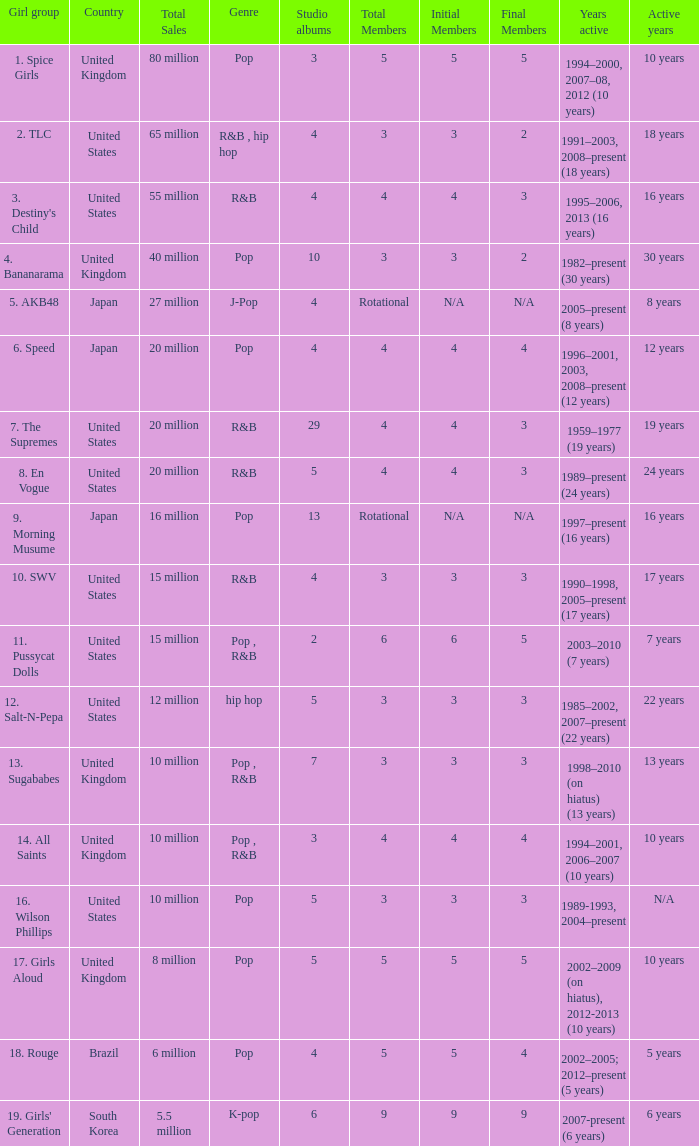Could you parse the entire table? {'header': ['Girl group', 'Country', 'Total Sales', 'Genre', 'Studio albums', 'Total Members', 'Initial Members', 'Final Members', 'Years active', 'Active years'], 'rows': [['1. Spice Girls', 'United Kingdom', '80 million', 'Pop', '3', '5', '5', '5', '1994–2000, 2007–08, 2012 (10 years)', '10 years'], ['2. TLC', 'United States', '65 million', 'R&B , hip hop', '4', '3', '3', '2', '1991–2003, 2008–present (18 years)', '18 years'], ["3. Destiny's Child", 'United States', '55 million', 'R&B', '4', '4', '4', '3', '1995–2006, 2013 (16 years)', '16 years'], ['4. Bananarama', 'United Kingdom', '40 million', 'Pop', '10', '3', '3', '2', '1982–present (30 years)', '30 years'], ['5. AKB48', 'Japan', '27 million', 'J-Pop', '4', 'Rotational', 'N/A', 'N/A', '2005–present (8 years)', '8 years'], ['6. Speed', 'Japan', '20 million', 'Pop', '4', '4', '4', '4', '1996–2001, 2003, 2008–present (12 years)', '12 years'], ['7. The Supremes', 'United States', '20 million', 'R&B', '29', '4', '4', '3', '1959–1977 (19 years)', '19 years'], ['8. En Vogue', 'United States', '20 million', 'R&B', '5', '4', '4', '3', '1989–present (24 years)', '24 years'], ['9. Morning Musume', 'Japan', '16 million', 'Pop', '13', 'Rotational', 'N/A', 'N/A', '1997–present (16 years)', '16 years'], ['10. SWV', 'United States', '15 million', 'R&B', '4', '3', '3', '3', '1990–1998, 2005–present (17 years)', '17 years'], ['11. Pussycat Dolls', 'United States', '15 million', 'Pop , R&B', '2', '6', '6', '5', '2003–2010 (7 years)', '7 years'], ['12. Salt-N-Pepa', 'United States', '12 million', 'hip hop', '5', '3', '3', '3', '1985–2002, 2007–present (22 years)', '22 years'], ['13. Sugababes', 'United Kingdom', '10 million', 'Pop , R&B', '7', '3', '3', '3', '1998–2010 (on hiatus) (13 years)', '13 years'], ['14. All Saints', 'United Kingdom', '10 million', 'Pop , R&B', '3', '4', '4', '4', '1994–2001, 2006–2007 (10 years)', '10 years'], ['16. Wilson Phillips', 'United States', '10 million', 'Pop', '5', '3', '3', '3', '1989-1993, 2004–present', 'N/A'], ['17. Girls Aloud', 'United Kingdom', '8 million', 'Pop', '5', '5', '5', '5', '2002–2009 (on hiatus), 2012-2013 (10 years)', '10 years'], ['18. Rouge', 'Brazil', '6 million', 'Pop', '4', '5', '5', '4', '2002–2005; 2012–present (5 years)', '5 years'], ["19. Girls' Generation", 'South Korea', '5.5 million', 'K-pop', '6', '9', '9', '9', '2007-present (6 years)', '6 years']]} What group had 29 studio albums? 7. The Supremes. 